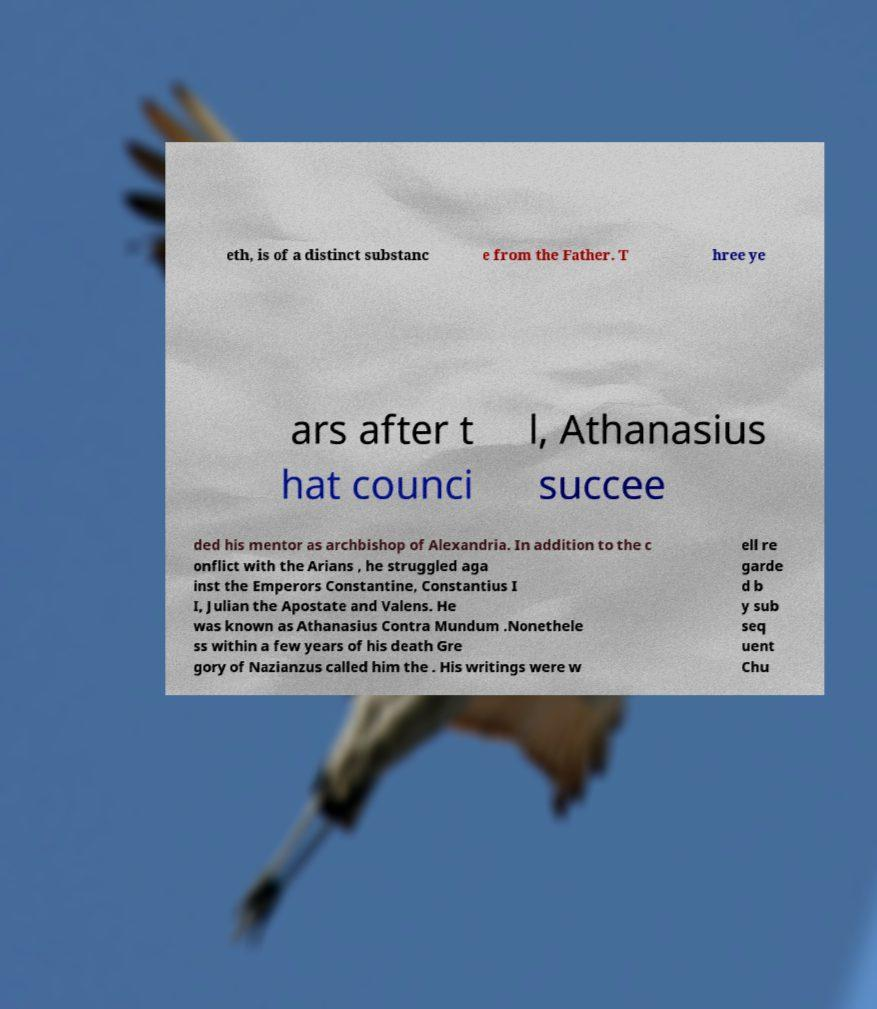Can you accurately transcribe the text from the provided image for me? eth, is of a distinct substanc e from the Father. T hree ye ars after t hat counci l, Athanasius succee ded his mentor as archbishop of Alexandria. In addition to the c onflict with the Arians , he struggled aga inst the Emperors Constantine, Constantius I I, Julian the Apostate and Valens. He was known as Athanasius Contra Mundum .Nonethele ss within a few years of his death Gre gory of Nazianzus called him the . His writings were w ell re garde d b y sub seq uent Chu 